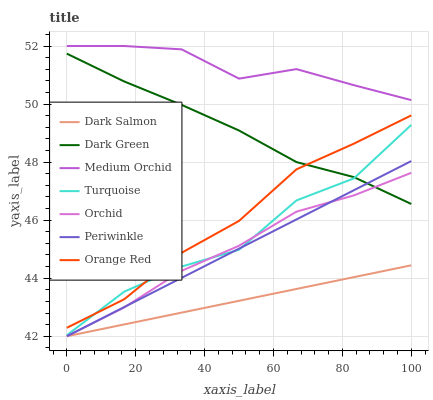Does Dark Salmon have the minimum area under the curve?
Answer yes or no. Yes. Does Medium Orchid have the maximum area under the curve?
Answer yes or no. Yes. Does Medium Orchid have the minimum area under the curve?
Answer yes or no. No. Does Dark Salmon have the maximum area under the curve?
Answer yes or no. No. Is Periwinkle the smoothest?
Answer yes or no. Yes. Is Turquoise the roughest?
Answer yes or no. Yes. Is Medium Orchid the smoothest?
Answer yes or no. No. Is Medium Orchid the roughest?
Answer yes or no. No. Does Dark Salmon have the lowest value?
Answer yes or no. Yes. Does Medium Orchid have the lowest value?
Answer yes or no. No. Does Medium Orchid have the highest value?
Answer yes or no. Yes. Does Dark Salmon have the highest value?
Answer yes or no. No. Is Dark Green less than Medium Orchid?
Answer yes or no. Yes. Is Dark Green greater than Dark Salmon?
Answer yes or no. Yes. Does Periwinkle intersect Turquoise?
Answer yes or no. Yes. Is Periwinkle less than Turquoise?
Answer yes or no. No. Is Periwinkle greater than Turquoise?
Answer yes or no. No. Does Dark Green intersect Medium Orchid?
Answer yes or no. No. 